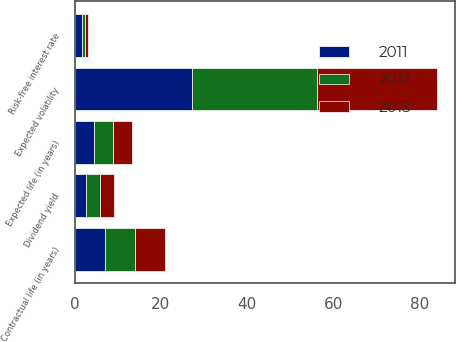<chart> <loc_0><loc_0><loc_500><loc_500><stacked_bar_chart><ecel><fcel>Expected volatility<fcel>Risk-free interest rate<fcel>Dividend yield<fcel>Expected life (in years)<fcel>Contractual life (in years)<nl><fcel>2012<fcel>28.9<fcel>0.7<fcel>3.2<fcel>4.5<fcel>7<nl><fcel>2013<fcel>27.8<fcel>0.8<fcel>3.2<fcel>4.5<fcel>7<nl><fcel>2011<fcel>27.3<fcel>1.7<fcel>2.7<fcel>4.4<fcel>7<nl></chart> 